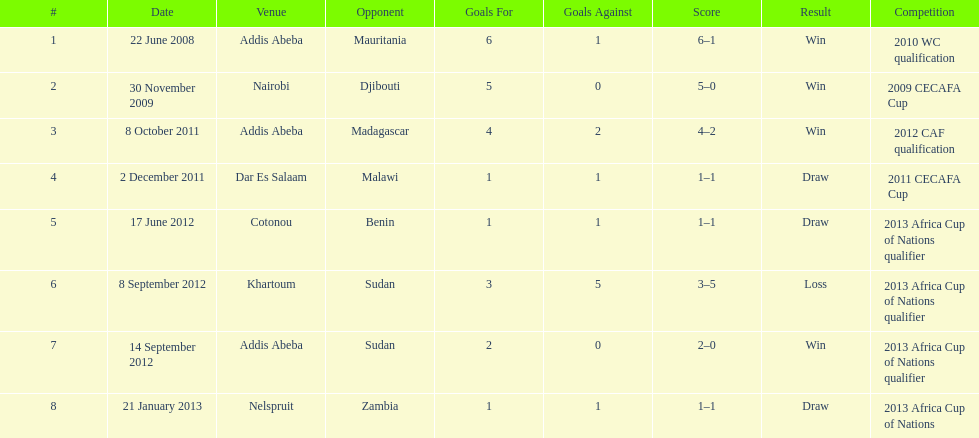How long in years down this table cover? 5. 